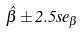Convert formula to latex. <formula><loc_0><loc_0><loc_500><loc_500>\hat { \beta } \pm 2 . 5 s e _ { \beta }</formula> 